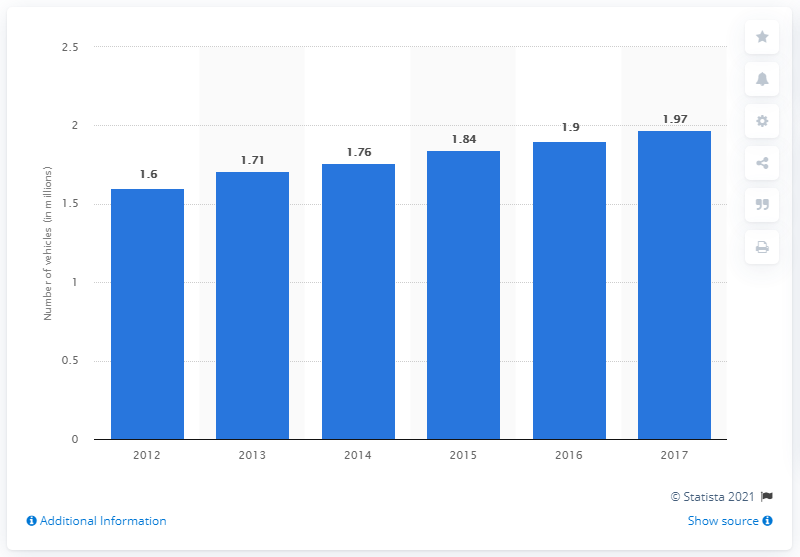Draw attention to some important aspects in this diagram. In 2012, it was projected that BMW's light vehicle production would begin. 